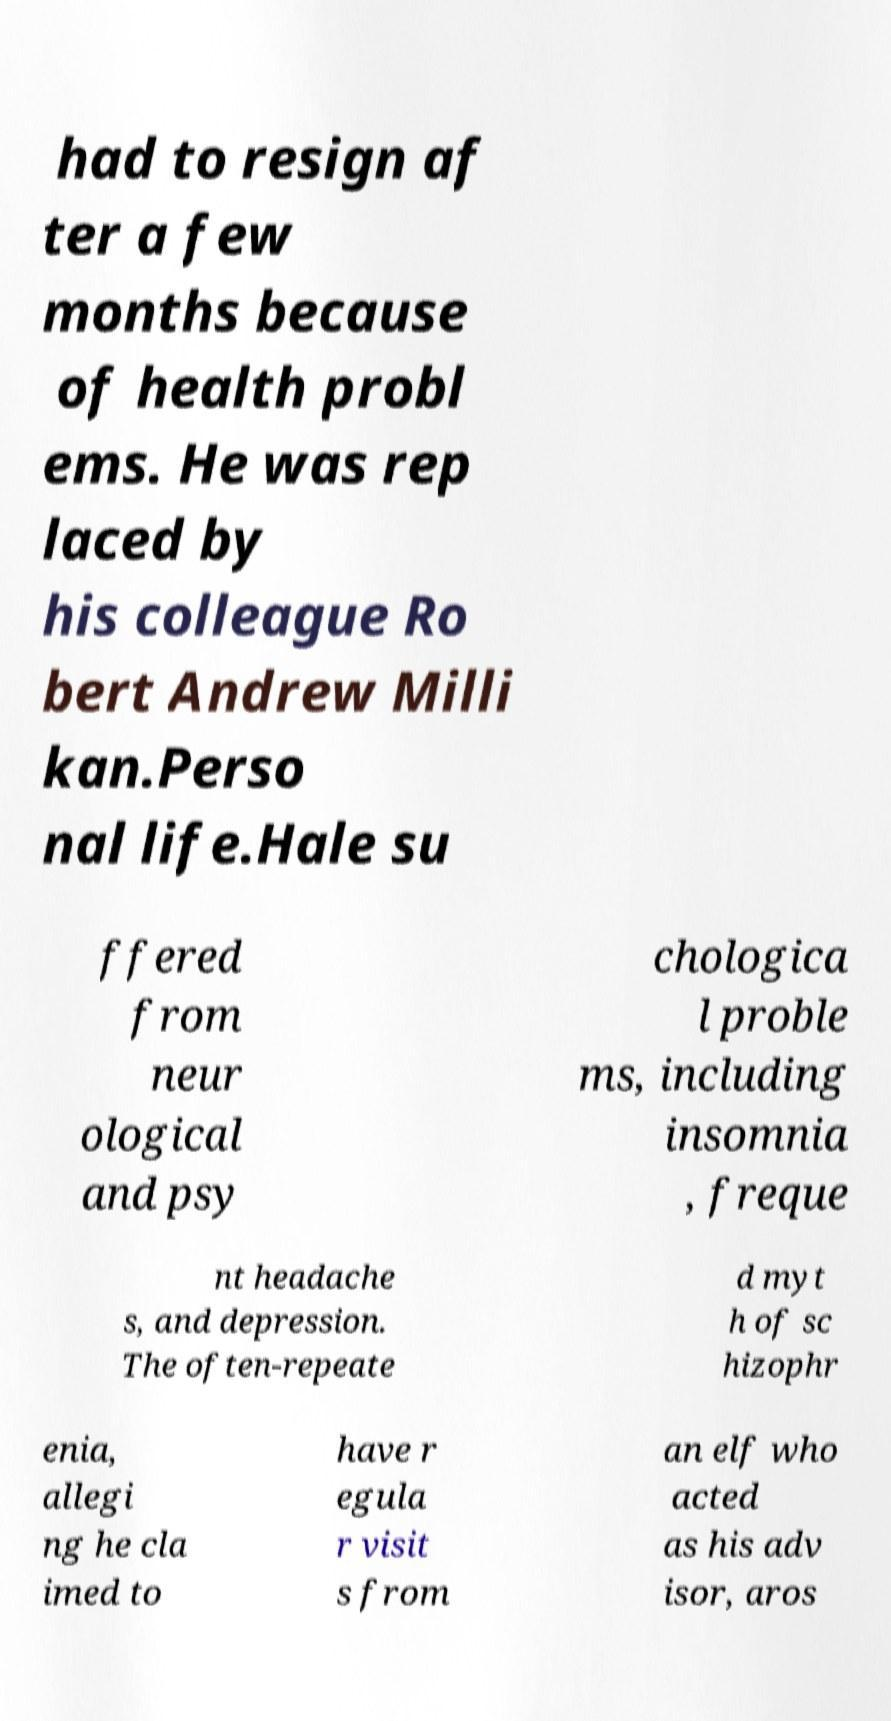Please identify and transcribe the text found in this image. had to resign af ter a few months because of health probl ems. He was rep laced by his colleague Ro bert Andrew Milli kan.Perso nal life.Hale su ffered from neur ological and psy chologica l proble ms, including insomnia , freque nt headache s, and depression. The often-repeate d myt h of sc hizophr enia, allegi ng he cla imed to have r egula r visit s from an elf who acted as his adv isor, aros 